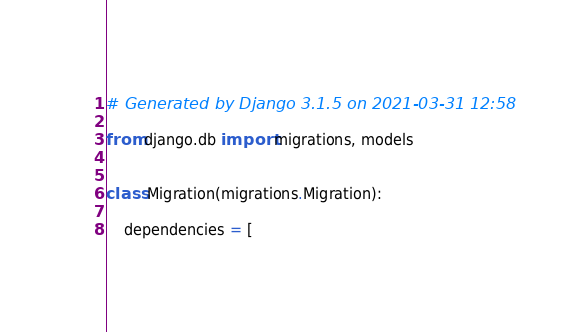Convert code to text. <code><loc_0><loc_0><loc_500><loc_500><_Python_># Generated by Django 3.1.5 on 2021-03-31 12:58

from django.db import migrations, models


class Migration(migrations.Migration):

    dependencies = [</code> 